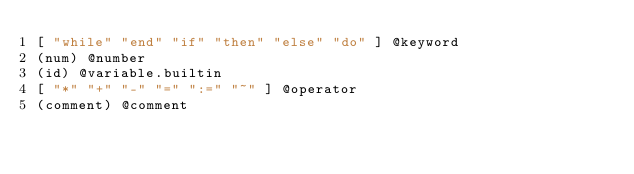Convert code to text. <code><loc_0><loc_0><loc_500><loc_500><_Scheme_>[ "while" "end" "if" "then" "else" "do" ] @keyword
(num) @number
(id) @variable.builtin
[ "*" "+" "-" "=" ":=" "~" ] @operator
(comment) @comment
</code> 